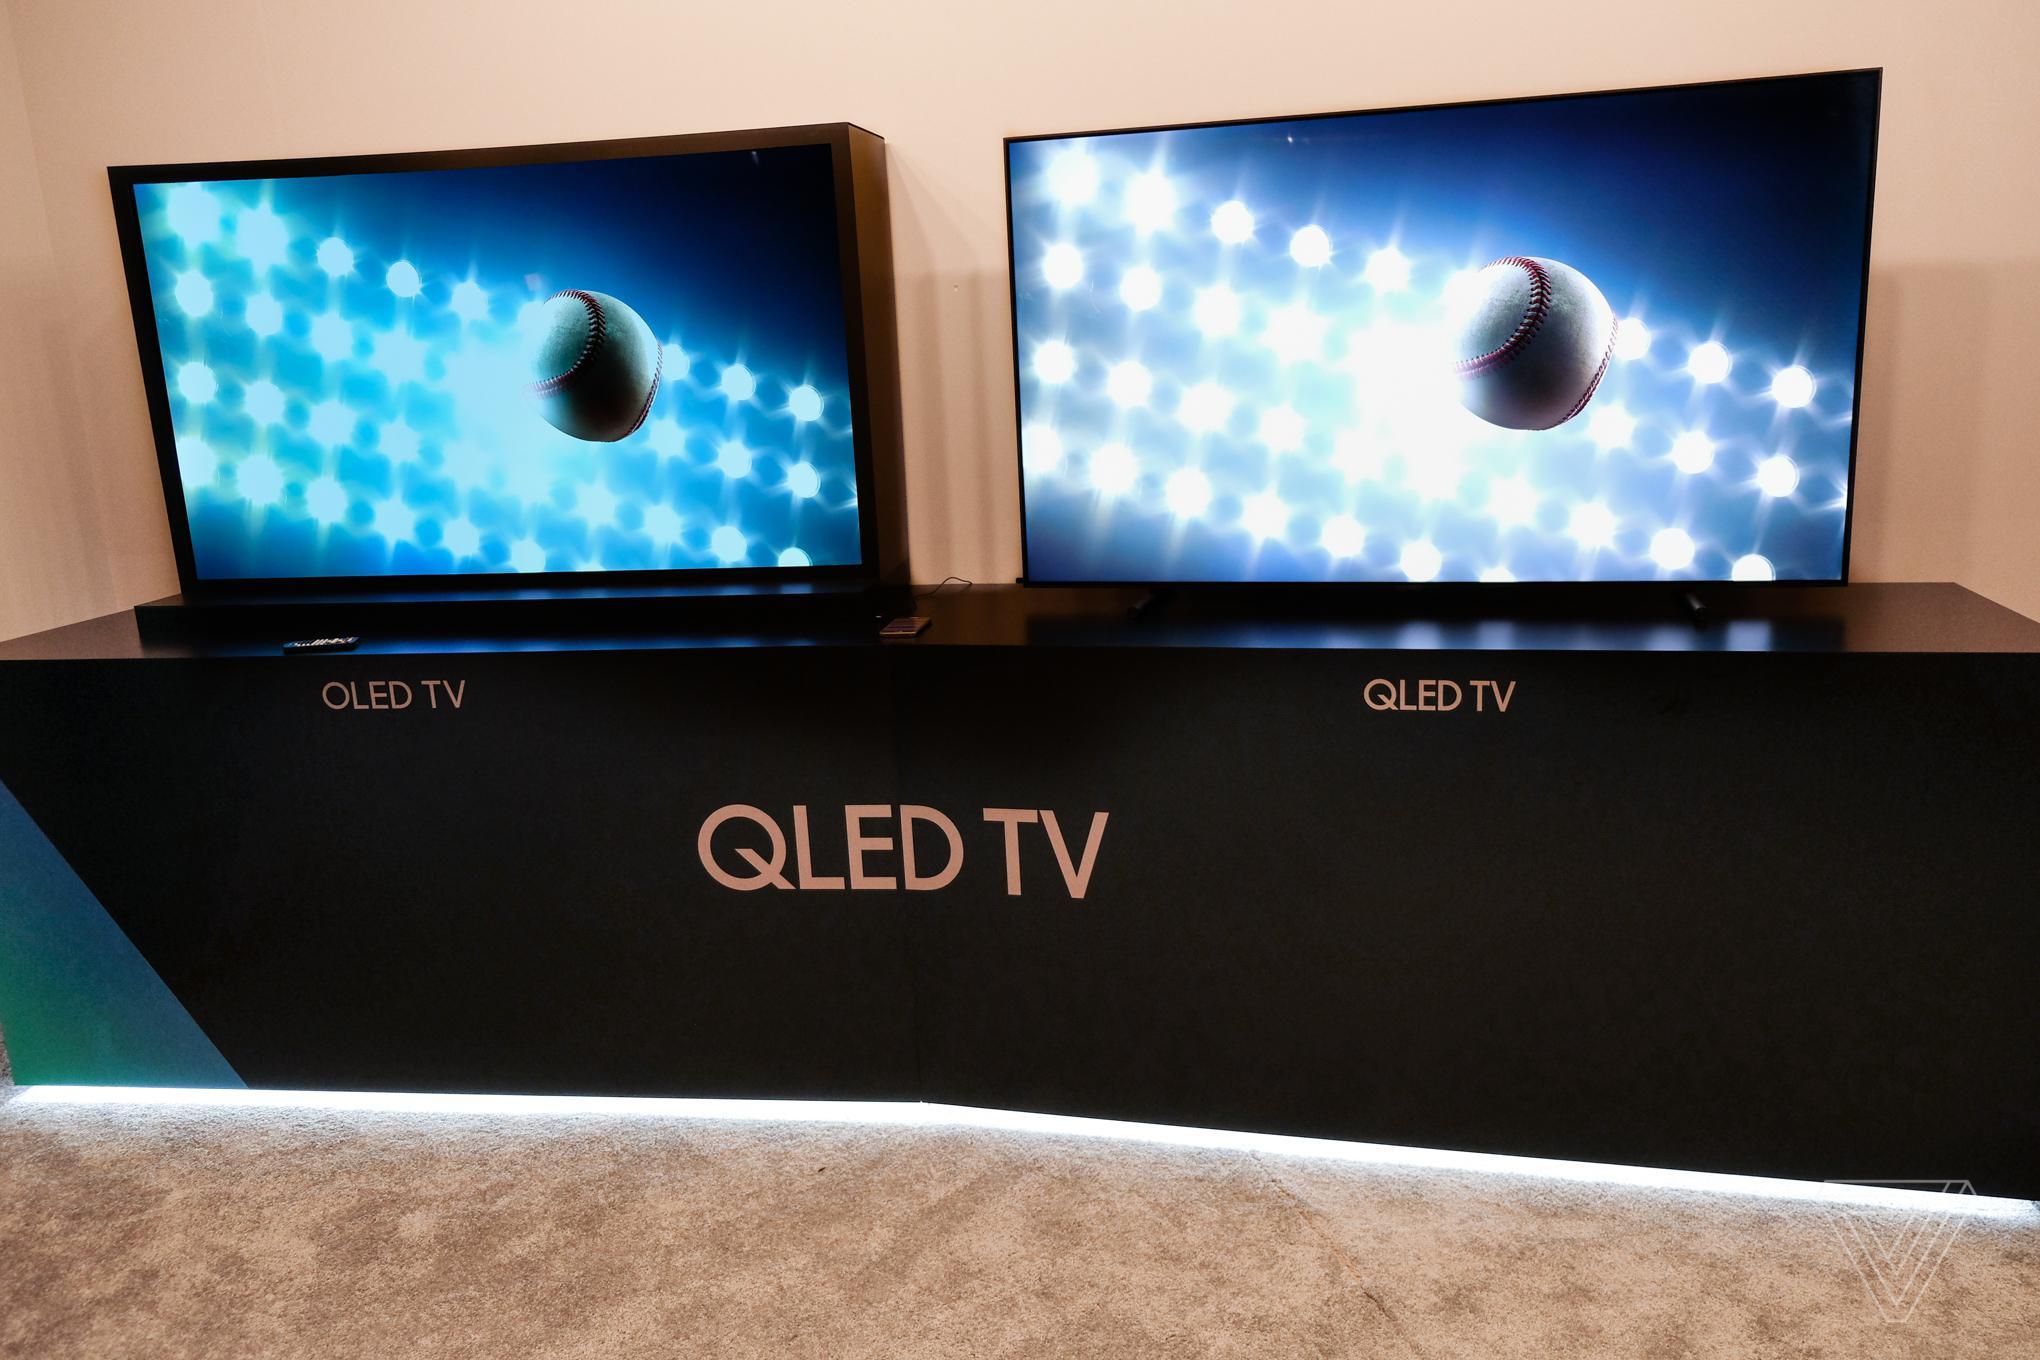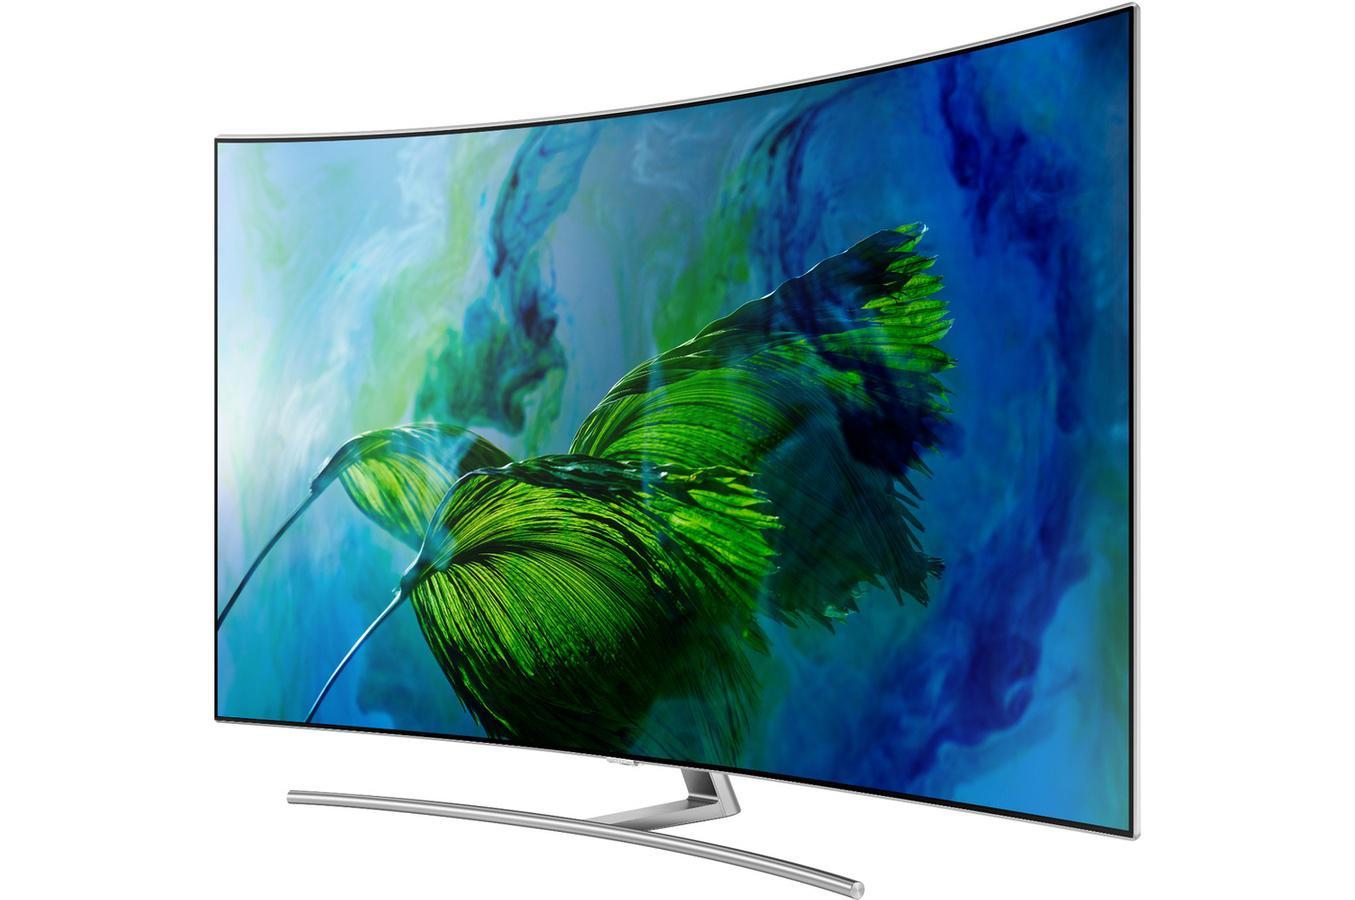The first image is the image on the left, the second image is the image on the right. For the images shown, is this caption "there is a curved tv on a metal stand with wording in the corner" true? Answer yes or no. No. The first image is the image on the left, the second image is the image on the right. Considering the images on both sides, is "Each image contains a single screen, and left and right images feature different pictures on the screens." valid? Answer yes or no. No. 